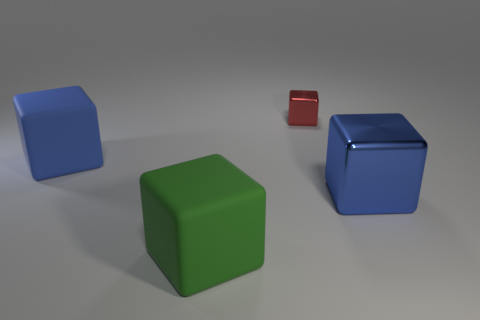Add 2 tiny green metallic spheres. How many objects exist? 6 Subtract all gray blocks. Subtract all red balls. How many blocks are left? 4 Subtract all small yellow things. Subtract all red metal things. How many objects are left? 3 Add 3 tiny red things. How many tiny red things are left? 4 Add 1 matte things. How many matte things exist? 3 Subtract 0 cyan cylinders. How many objects are left? 4 